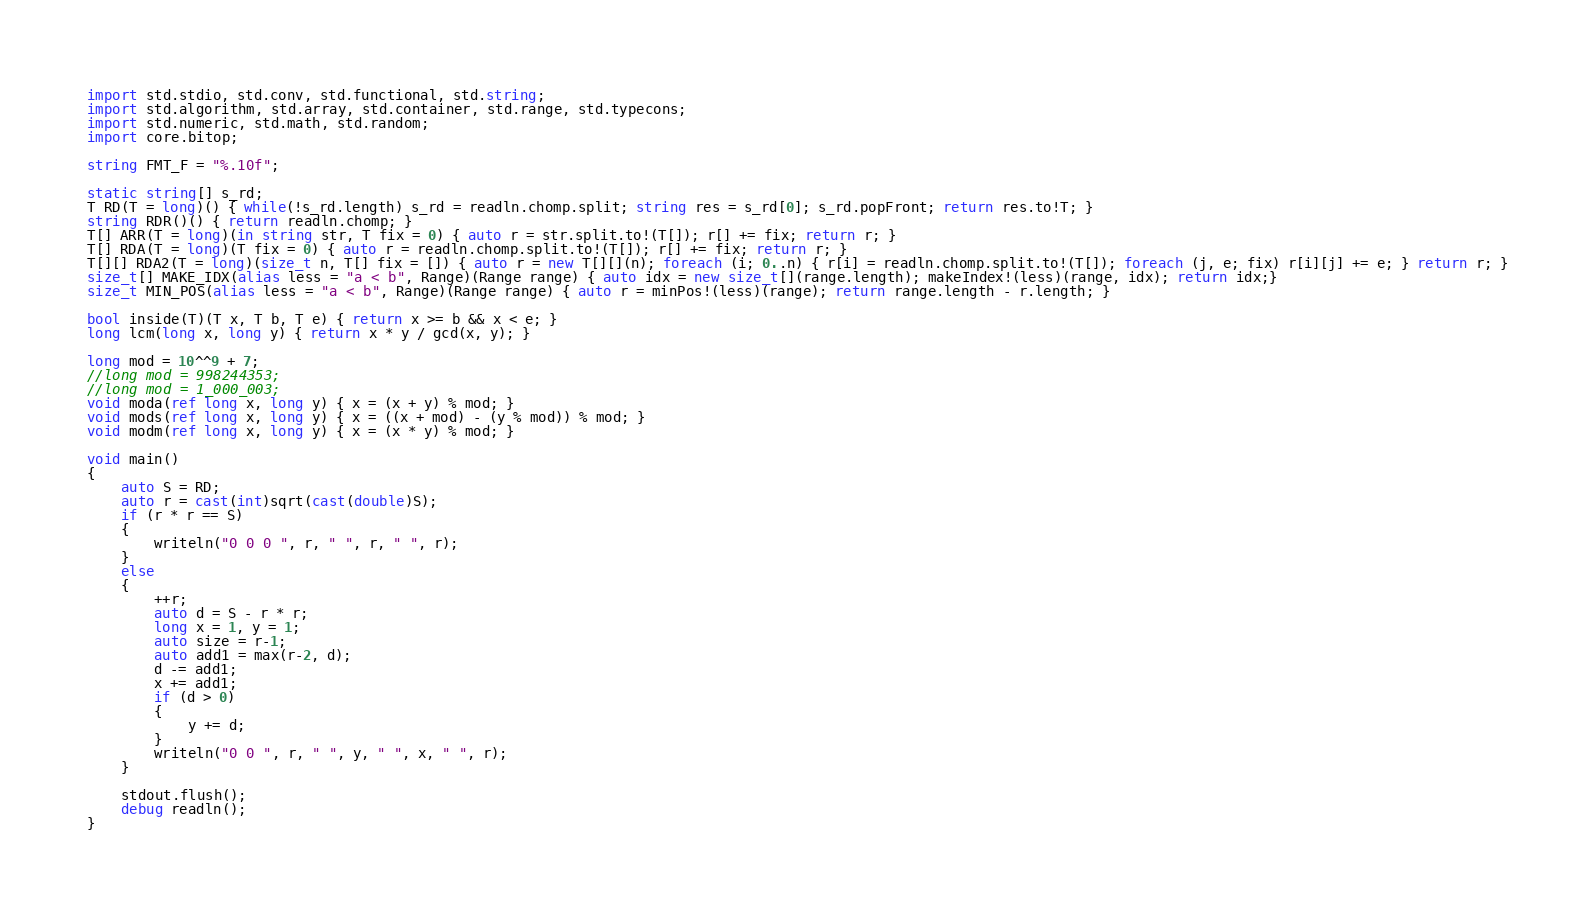<code> <loc_0><loc_0><loc_500><loc_500><_D_>import std.stdio, std.conv, std.functional, std.string;
import std.algorithm, std.array, std.container, std.range, std.typecons;
import std.numeric, std.math, std.random;
import core.bitop;

string FMT_F = "%.10f";

static string[] s_rd;
T RD(T = long)() { while(!s_rd.length) s_rd = readln.chomp.split; string res = s_rd[0]; s_rd.popFront; return res.to!T; }
string RDR()() { return readln.chomp; }
T[] ARR(T = long)(in string str, T fix = 0) { auto r = str.split.to!(T[]); r[] += fix; return r; }
T[] RDA(T = long)(T fix = 0) { auto r = readln.chomp.split.to!(T[]); r[] += fix; return r; }
T[][] RDA2(T = long)(size_t n, T[] fix = []) { auto r = new T[][](n); foreach (i; 0..n) { r[i] = readln.chomp.split.to!(T[]); foreach (j, e; fix) r[i][j] += e; } return r; }
size_t[] MAKE_IDX(alias less = "a < b", Range)(Range range) { auto idx = new size_t[](range.length); makeIndex!(less)(range, idx); return idx;}
size_t MIN_POS(alias less = "a < b", Range)(Range range) { auto r = minPos!(less)(range); return range.length - r.length; }

bool inside(T)(T x, T b, T e) { return x >= b && x < e; }
long lcm(long x, long y) { return x * y / gcd(x, y); }

long mod = 10^^9 + 7;
//long mod = 998244353;
//long mod = 1_000_003;
void moda(ref long x, long y) { x = (x + y) % mod; }
void mods(ref long x, long y) { x = ((x + mod) - (y % mod)) % mod; }
void modm(ref long x, long y) { x = (x * y) % mod; }

void main()
{
	auto S = RD;
	auto r = cast(int)sqrt(cast(double)S);
	if (r * r == S)
	{
		writeln("0 0 0 ", r, " ", r, " ", r);
	}
	else
	{
		++r;
		auto d = S - r * r;
		long x = 1, y = 1;
		auto size = r-1;
		auto add1 = max(r-2, d);
		d -= add1;
		x += add1;
		if (d > 0)
		{
			y += d;
		}
		writeln("0 0 ", r, " ", y, " ", x, " ", r);
	}

	stdout.flush();
	debug readln();
}
</code> 